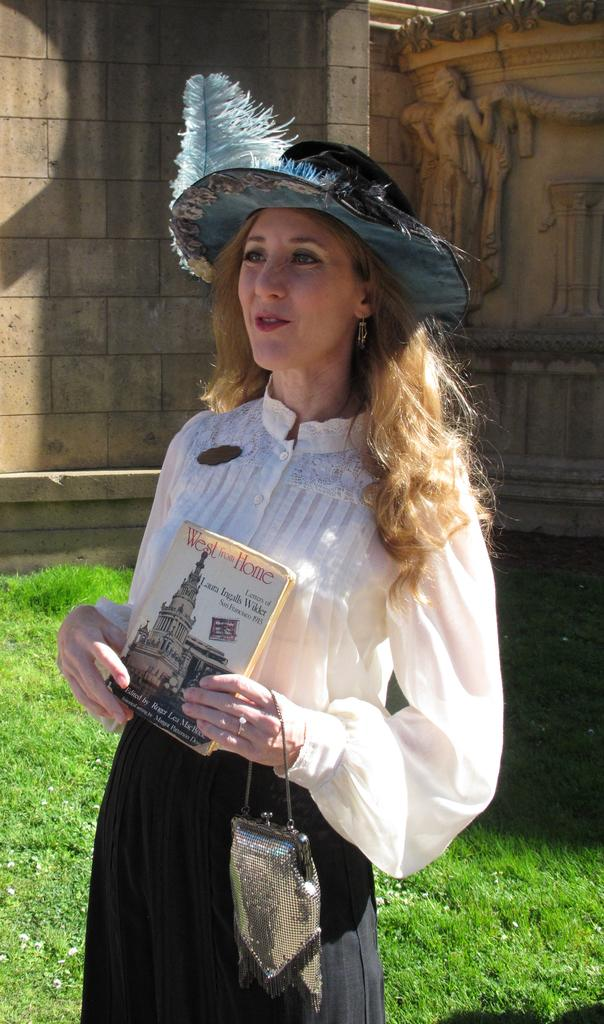Who is the main subject in the image? There is a woman in the image. Where is the woman located in the image? The woman is standing in the middle of the image. What is the woman holding in the image? The woman is holding a bag and a book. What can be seen in the background of the image? There is grass and a wall visible in the background of the image. What is on the wall in the background? There is a sculpture on the wall. What time of day is it in the image, and how does the woman plan to stop it? The time of day is not mentioned in the image, and there is no indication that the woman is trying to stop anything. 